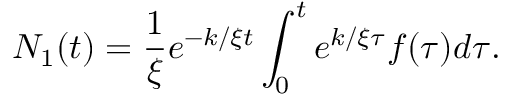<formula> <loc_0><loc_0><loc_500><loc_500>N _ { 1 } ( t ) = \frac { 1 } { \xi } e ^ { - k / \xi t } \int _ { 0 } ^ { t } e ^ { k / \xi \tau } f ( \tau ) d \tau .</formula> 